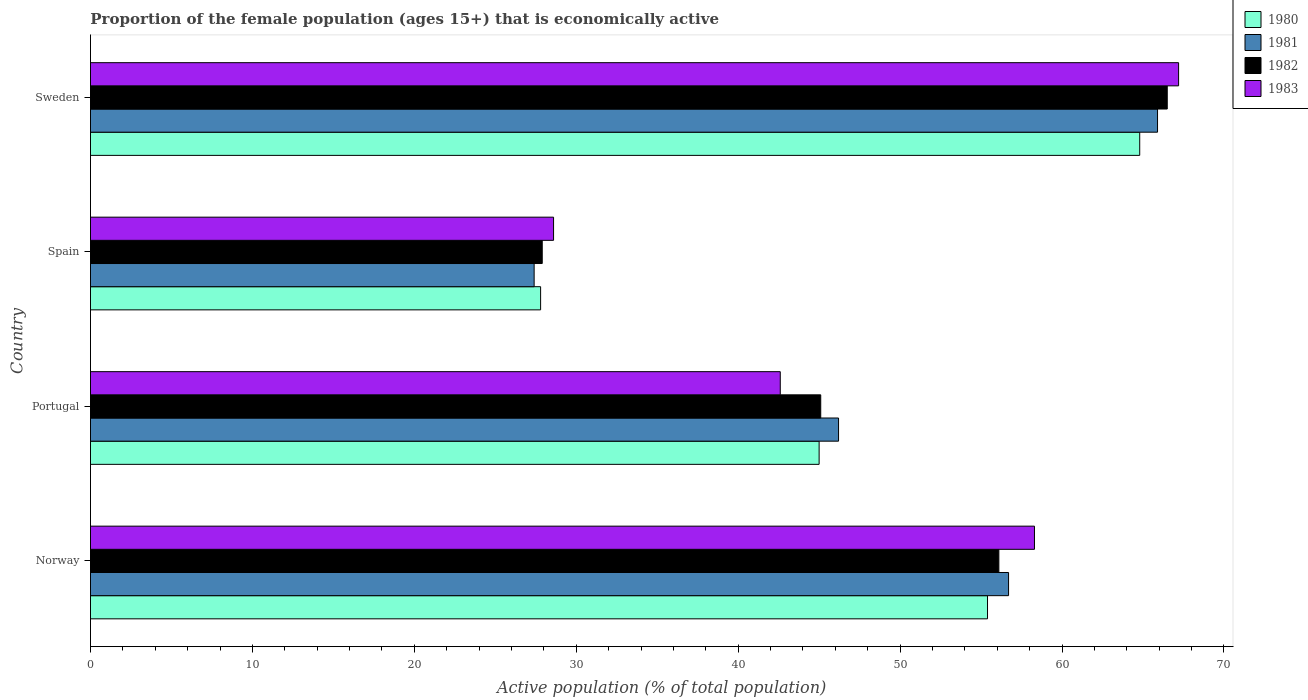Are the number of bars per tick equal to the number of legend labels?
Offer a terse response. Yes. Are the number of bars on each tick of the Y-axis equal?
Keep it short and to the point. Yes. How many bars are there on the 2nd tick from the top?
Provide a short and direct response. 4. What is the proportion of the female population that is economically active in 1981 in Portugal?
Give a very brief answer. 46.2. Across all countries, what is the maximum proportion of the female population that is economically active in 1983?
Your answer should be compact. 67.2. Across all countries, what is the minimum proportion of the female population that is economically active in 1982?
Ensure brevity in your answer.  27.9. In which country was the proportion of the female population that is economically active in 1983 maximum?
Offer a terse response. Sweden. In which country was the proportion of the female population that is economically active in 1980 minimum?
Provide a short and direct response. Spain. What is the total proportion of the female population that is economically active in 1980 in the graph?
Make the answer very short. 193. What is the difference between the proportion of the female population that is economically active in 1980 in Norway and that in Portugal?
Ensure brevity in your answer.  10.4. What is the difference between the proportion of the female population that is economically active in 1980 in Portugal and the proportion of the female population that is economically active in 1983 in Spain?
Offer a very short reply. 16.4. What is the average proportion of the female population that is economically active in 1980 per country?
Provide a short and direct response. 48.25. What is the difference between the proportion of the female population that is economically active in 1981 and proportion of the female population that is economically active in 1980 in Spain?
Your answer should be compact. -0.4. What is the ratio of the proportion of the female population that is economically active in 1982 in Spain to that in Sweden?
Provide a succinct answer. 0.42. What is the difference between the highest and the second highest proportion of the female population that is economically active in 1981?
Make the answer very short. 9.2. What is the difference between the highest and the lowest proportion of the female population that is economically active in 1981?
Offer a very short reply. 38.5. What does the 4th bar from the top in Sweden represents?
Ensure brevity in your answer.  1980. What does the 3rd bar from the bottom in Spain represents?
Ensure brevity in your answer.  1982. Is it the case that in every country, the sum of the proportion of the female population that is economically active in 1981 and proportion of the female population that is economically active in 1983 is greater than the proportion of the female population that is economically active in 1982?
Your response must be concise. Yes. Are all the bars in the graph horizontal?
Offer a terse response. Yes. How many countries are there in the graph?
Keep it short and to the point. 4. Are the values on the major ticks of X-axis written in scientific E-notation?
Offer a terse response. No. Does the graph contain any zero values?
Keep it short and to the point. No. Where does the legend appear in the graph?
Give a very brief answer. Top right. How many legend labels are there?
Your answer should be compact. 4. What is the title of the graph?
Offer a terse response. Proportion of the female population (ages 15+) that is economically active. What is the label or title of the X-axis?
Make the answer very short. Active population (% of total population). What is the label or title of the Y-axis?
Your answer should be compact. Country. What is the Active population (% of total population) of 1980 in Norway?
Ensure brevity in your answer.  55.4. What is the Active population (% of total population) of 1981 in Norway?
Your answer should be compact. 56.7. What is the Active population (% of total population) of 1982 in Norway?
Your response must be concise. 56.1. What is the Active population (% of total population) of 1983 in Norway?
Provide a short and direct response. 58.3. What is the Active population (% of total population) of 1981 in Portugal?
Your answer should be compact. 46.2. What is the Active population (% of total population) of 1982 in Portugal?
Offer a very short reply. 45.1. What is the Active population (% of total population) in 1983 in Portugal?
Ensure brevity in your answer.  42.6. What is the Active population (% of total population) of 1980 in Spain?
Offer a terse response. 27.8. What is the Active population (% of total population) of 1981 in Spain?
Your answer should be very brief. 27.4. What is the Active population (% of total population) in 1982 in Spain?
Your response must be concise. 27.9. What is the Active population (% of total population) of 1983 in Spain?
Ensure brevity in your answer.  28.6. What is the Active population (% of total population) of 1980 in Sweden?
Ensure brevity in your answer.  64.8. What is the Active population (% of total population) of 1981 in Sweden?
Ensure brevity in your answer.  65.9. What is the Active population (% of total population) of 1982 in Sweden?
Keep it short and to the point. 66.5. What is the Active population (% of total population) in 1983 in Sweden?
Offer a very short reply. 67.2. Across all countries, what is the maximum Active population (% of total population) in 1980?
Keep it short and to the point. 64.8. Across all countries, what is the maximum Active population (% of total population) in 1981?
Your response must be concise. 65.9. Across all countries, what is the maximum Active population (% of total population) in 1982?
Offer a very short reply. 66.5. Across all countries, what is the maximum Active population (% of total population) in 1983?
Keep it short and to the point. 67.2. Across all countries, what is the minimum Active population (% of total population) in 1980?
Your answer should be very brief. 27.8. Across all countries, what is the minimum Active population (% of total population) in 1981?
Your response must be concise. 27.4. Across all countries, what is the minimum Active population (% of total population) of 1982?
Give a very brief answer. 27.9. Across all countries, what is the minimum Active population (% of total population) in 1983?
Make the answer very short. 28.6. What is the total Active population (% of total population) of 1980 in the graph?
Offer a very short reply. 193. What is the total Active population (% of total population) of 1981 in the graph?
Offer a very short reply. 196.2. What is the total Active population (% of total population) in 1982 in the graph?
Provide a succinct answer. 195.6. What is the total Active population (% of total population) of 1983 in the graph?
Provide a succinct answer. 196.7. What is the difference between the Active population (% of total population) in 1980 in Norway and that in Portugal?
Make the answer very short. 10.4. What is the difference between the Active population (% of total population) in 1981 in Norway and that in Portugal?
Provide a succinct answer. 10.5. What is the difference between the Active population (% of total population) in 1982 in Norway and that in Portugal?
Provide a succinct answer. 11. What is the difference between the Active population (% of total population) in 1983 in Norway and that in Portugal?
Provide a succinct answer. 15.7. What is the difference between the Active population (% of total population) in 1980 in Norway and that in Spain?
Your response must be concise. 27.6. What is the difference between the Active population (% of total population) of 1981 in Norway and that in Spain?
Offer a very short reply. 29.3. What is the difference between the Active population (% of total population) in 1982 in Norway and that in Spain?
Your answer should be compact. 28.2. What is the difference between the Active population (% of total population) in 1983 in Norway and that in Spain?
Make the answer very short. 29.7. What is the difference between the Active population (% of total population) of 1980 in Norway and that in Sweden?
Your response must be concise. -9.4. What is the difference between the Active population (% of total population) of 1981 in Norway and that in Sweden?
Keep it short and to the point. -9.2. What is the difference between the Active population (% of total population) in 1982 in Norway and that in Sweden?
Ensure brevity in your answer.  -10.4. What is the difference between the Active population (% of total population) in 1983 in Norway and that in Sweden?
Your answer should be compact. -8.9. What is the difference between the Active population (% of total population) of 1980 in Portugal and that in Spain?
Offer a terse response. 17.2. What is the difference between the Active population (% of total population) of 1980 in Portugal and that in Sweden?
Ensure brevity in your answer.  -19.8. What is the difference between the Active population (% of total population) in 1981 in Portugal and that in Sweden?
Offer a very short reply. -19.7. What is the difference between the Active population (% of total population) of 1982 in Portugal and that in Sweden?
Ensure brevity in your answer.  -21.4. What is the difference between the Active population (% of total population) in 1983 in Portugal and that in Sweden?
Ensure brevity in your answer.  -24.6. What is the difference between the Active population (% of total population) of 1980 in Spain and that in Sweden?
Give a very brief answer. -37. What is the difference between the Active population (% of total population) of 1981 in Spain and that in Sweden?
Offer a very short reply. -38.5. What is the difference between the Active population (% of total population) in 1982 in Spain and that in Sweden?
Provide a short and direct response. -38.6. What is the difference between the Active population (% of total population) of 1983 in Spain and that in Sweden?
Offer a very short reply. -38.6. What is the difference between the Active population (% of total population) of 1980 in Norway and the Active population (% of total population) of 1981 in Portugal?
Make the answer very short. 9.2. What is the difference between the Active population (% of total population) in 1980 in Norway and the Active population (% of total population) in 1983 in Spain?
Provide a succinct answer. 26.8. What is the difference between the Active population (% of total population) of 1981 in Norway and the Active population (% of total population) of 1982 in Spain?
Give a very brief answer. 28.8. What is the difference between the Active population (% of total population) of 1981 in Norway and the Active population (% of total population) of 1983 in Spain?
Offer a terse response. 28.1. What is the difference between the Active population (% of total population) in 1982 in Norway and the Active population (% of total population) in 1983 in Spain?
Your answer should be very brief. 27.5. What is the difference between the Active population (% of total population) of 1981 in Norway and the Active population (% of total population) of 1982 in Sweden?
Keep it short and to the point. -9.8. What is the difference between the Active population (% of total population) of 1981 in Norway and the Active population (% of total population) of 1983 in Sweden?
Keep it short and to the point. -10.5. What is the difference between the Active population (% of total population) in 1980 in Portugal and the Active population (% of total population) in 1983 in Spain?
Your answer should be compact. 16.4. What is the difference between the Active population (% of total population) of 1981 in Portugal and the Active population (% of total population) of 1982 in Spain?
Offer a terse response. 18.3. What is the difference between the Active population (% of total population) of 1982 in Portugal and the Active population (% of total population) of 1983 in Spain?
Ensure brevity in your answer.  16.5. What is the difference between the Active population (% of total population) of 1980 in Portugal and the Active population (% of total population) of 1981 in Sweden?
Provide a short and direct response. -20.9. What is the difference between the Active population (% of total population) of 1980 in Portugal and the Active population (% of total population) of 1982 in Sweden?
Offer a very short reply. -21.5. What is the difference between the Active population (% of total population) of 1980 in Portugal and the Active population (% of total population) of 1983 in Sweden?
Keep it short and to the point. -22.2. What is the difference between the Active population (% of total population) of 1981 in Portugal and the Active population (% of total population) of 1982 in Sweden?
Your response must be concise. -20.3. What is the difference between the Active population (% of total population) of 1982 in Portugal and the Active population (% of total population) of 1983 in Sweden?
Keep it short and to the point. -22.1. What is the difference between the Active population (% of total population) in 1980 in Spain and the Active population (% of total population) in 1981 in Sweden?
Your answer should be very brief. -38.1. What is the difference between the Active population (% of total population) in 1980 in Spain and the Active population (% of total population) in 1982 in Sweden?
Provide a succinct answer. -38.7. What is the difference between the Active population (% of total population) in 1980 in Spain and the Active population (% of total population) in 1983 in Sweden?
Make the answer very short. -39.4. What is the difference between the Active population (% of total population) in 1981 in Spain and the Active population (% of total population) in 1982 in Sweden?
Offer a very short reply. -39.1. What is the difference between the Active population (% of total population) in 1981 in Spain and the Active population (% of total population) in 1983 in Sweden?
Your response must be concise. -39.8. What is the difference between the Active population (% of total population) in 1982 in Spain and the Active population (% of total population) in 1983 in Sweden?
Offer a terse response. -39.3. What is the average Active population (% of total population) of 1980 per country?
Your answer should be compact. 48.25. What is the average Active population (% of total population) in 1981 per country?
Make the answer very short. 49.05. What is the average Active population (% of total population) of 1982 per country?
Make the answer very short. 48.9. What is the average Active population (% of total population) of 1983 per country?
Keep it short and to the point. 49.17. What is the difference between the Active population (% of total population) of 1980 and Active population (% of total population) of 1983 in Norway?
Your answer should be compact. -2.9. What is the difference between the Active population (% of total population) of 1981 and Active population (% of total population) of 1983 in Norway?
Your answer should be compact. -1.6. What is the difference between the Active population (% of total population) of 1982 and Active population (% of total population) of 1983 in Norway?
Your answer should be compact. -2.2. What is the difference between the Active population (% of total population) of 1980 and Active population (% of total population) of 1981 in Portugal?
Your answer should be compact. -1.2. What is the difference between the Active population (% of total population) of 1981 and Active population (% of total population) of 1982 in Portugal?
Your response must be concise. 1.1. What is the difference between the Active population (% of total population) of 1982 and Active population (% of total population) of 1983 in Portugal?
Keep it short and to the point. 2.5. What is the difference between the Active population (% of total population) in 1980 and Active population (% of total population) in 1981 in Spain?
Keep it short and to the point. 0.4. What is the difference between the Active population (% of total population) in 1980 and Active population (% of total population) in 1983 in Spain?
Your answer should be very brief. -0.8. What is the difference between the Active population (% of total population) in 1981 and Active population (% of total population) in 1983 in Spain?
Ensure brevity in your answer.  -1.2. What is the difference between the Active population (% of total population) of 1980 and Active population (% of total population) of 1982 in Sweden?
Offer a terse response. -1.7. What is the difference between the Active population (% of total population) of 1982 and Active population (% of total population) of 1983 in Sweden?
Provide a short and direct response. -0.7. What is the ratio of the Active population (% of total population) in 1980 in Norway to that in Portugal?
Your answer should be compact. 1.23. What is the ratio of the Active population (% of total population) in 1981 in Norway to that in Portugal?
Keep it short and to the point. 1.23. What is the ratio of the Active population (% of total population) in 1982 in Norway to that in Portugal?
Your answer should be compact. 1.24. What is the ratio of the Active population (% of total population) in 1983 in Norway to that in Portugal?
Make the answer very short. 1.37. What is the ratio of the Active population (% of total population) of 1980 in Norway to that in Spain?
Offer a terse response. 1.99. What is the ratio of the Active population (% of total population) in 1981 in Norway to that in Spain?
Keep it short and to the point. 2.07. What is the ratio of the Active population (% of total population) in 1982 in Norway to that in Spain?
Ensure brevity in your answer.  2.01. What is the ratio of the Active population (% of total population) of 1983 in Norway to that in Spain?
Give a very brief answer. 2.04. What is the ratio of the Active population (% of total population) in 1980 in Norway to that in Sweden?
Keep it short and to the point. 0.85. What is the ratio of the Active population (% of total population) of 1981 in Norway to that in Sweden?
Your answer should be compact. 0.86. What is the ratio of the Active population (% of total population) of 1982 in Norway to that in Sweden?
Offer a terse response. 0.84. What is the ratio of the Active population (% of total population) of 1983 in Norway to that in Sweden?
Make the answer very short. 0.87. What is the ratio of the Active population (% of total population) of 1980 in Portugal to that in Spain?
Your answer should be compact. 1.62. What is the ratio of the Active population (% of total population) of 1981 in Portugal to that in Spain?
Your answer should be very brief. 1.69. What is the ratio of the Active population (% of total population) in 1982 in Portugal to that in Spain?
Ensure brevity in your answer.  1.62. What is the ratio of the Active population (% of total population) in 1983 in Portugal to that in Spain?
Ensure brevity in your answer.  1.49. What is the ratio of the Active population (% of total population) in 1980 in Portugal to that in Sweden?
Your answer should be compact. 0.69. What is the ratio of the Active population (% of total population) in 1981 in Portugal to that in Sweden?
Provide a short and direct response. 0.7. What is the ratio of the Active population (% of total population) in 1982 in Portugal to that in Sweden?
Provide a short and direct response. 0.68. What is the ratio of the Active population (% of total population) of 1983 in Portugal to that in Sweden?
Give a very brief answer. 0.63. What is the ratio of the Active population (% of total population) of 1980 in Spain to that in Sweden?
Make the answer very short. 0.43. What is the ratio of the Active population (% of total population) of 1981 in Spain to that in Sweden?
Ensure brevity in your answer.  0.42. What is the ratio of the Active population (% of total population) of 1982 in Spain to that in Sweden?
Your answer should be very brief. 0.42. What is the ratio of the Active population (% of total population) of 1983 in Spain to that in Sweden?
Offer a terse response. 0.43. What is the difference between the highest and the lowest Active population (% of total population) of 1980?
Your response must be concise. 37. What is the difference between the highest and the lowest Active population (% of total population) of 1981?
Ensure brevity in your answer.  38.5. What is the difference between the highest and the lowest Active population (% of total population) of 1982?
Ensure brevity in your answer.  38.6. What is the difference between the highest and the lowest Active population (% of total population) of 1983?
Give a very brief answer. 38.6. 